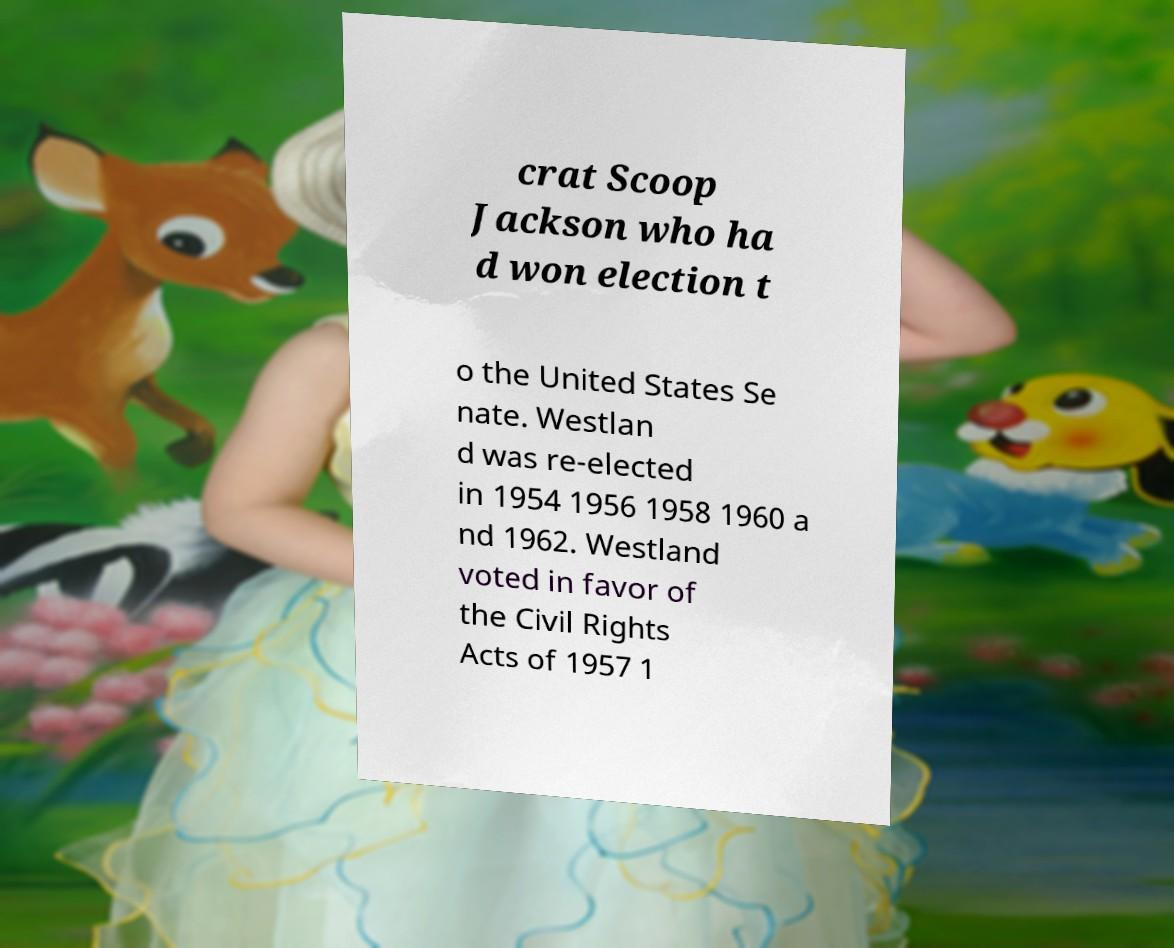What messages or text are displayed in this image? I need them in a readable, typed format. crat Scoop Jackson who ha d won election t o the United States Se nate. Westlan d was re-elected in 1954 1956 1958 1960 a nd 1962. Westland voted in favor of the Civil Rights Acts of 1957 1 